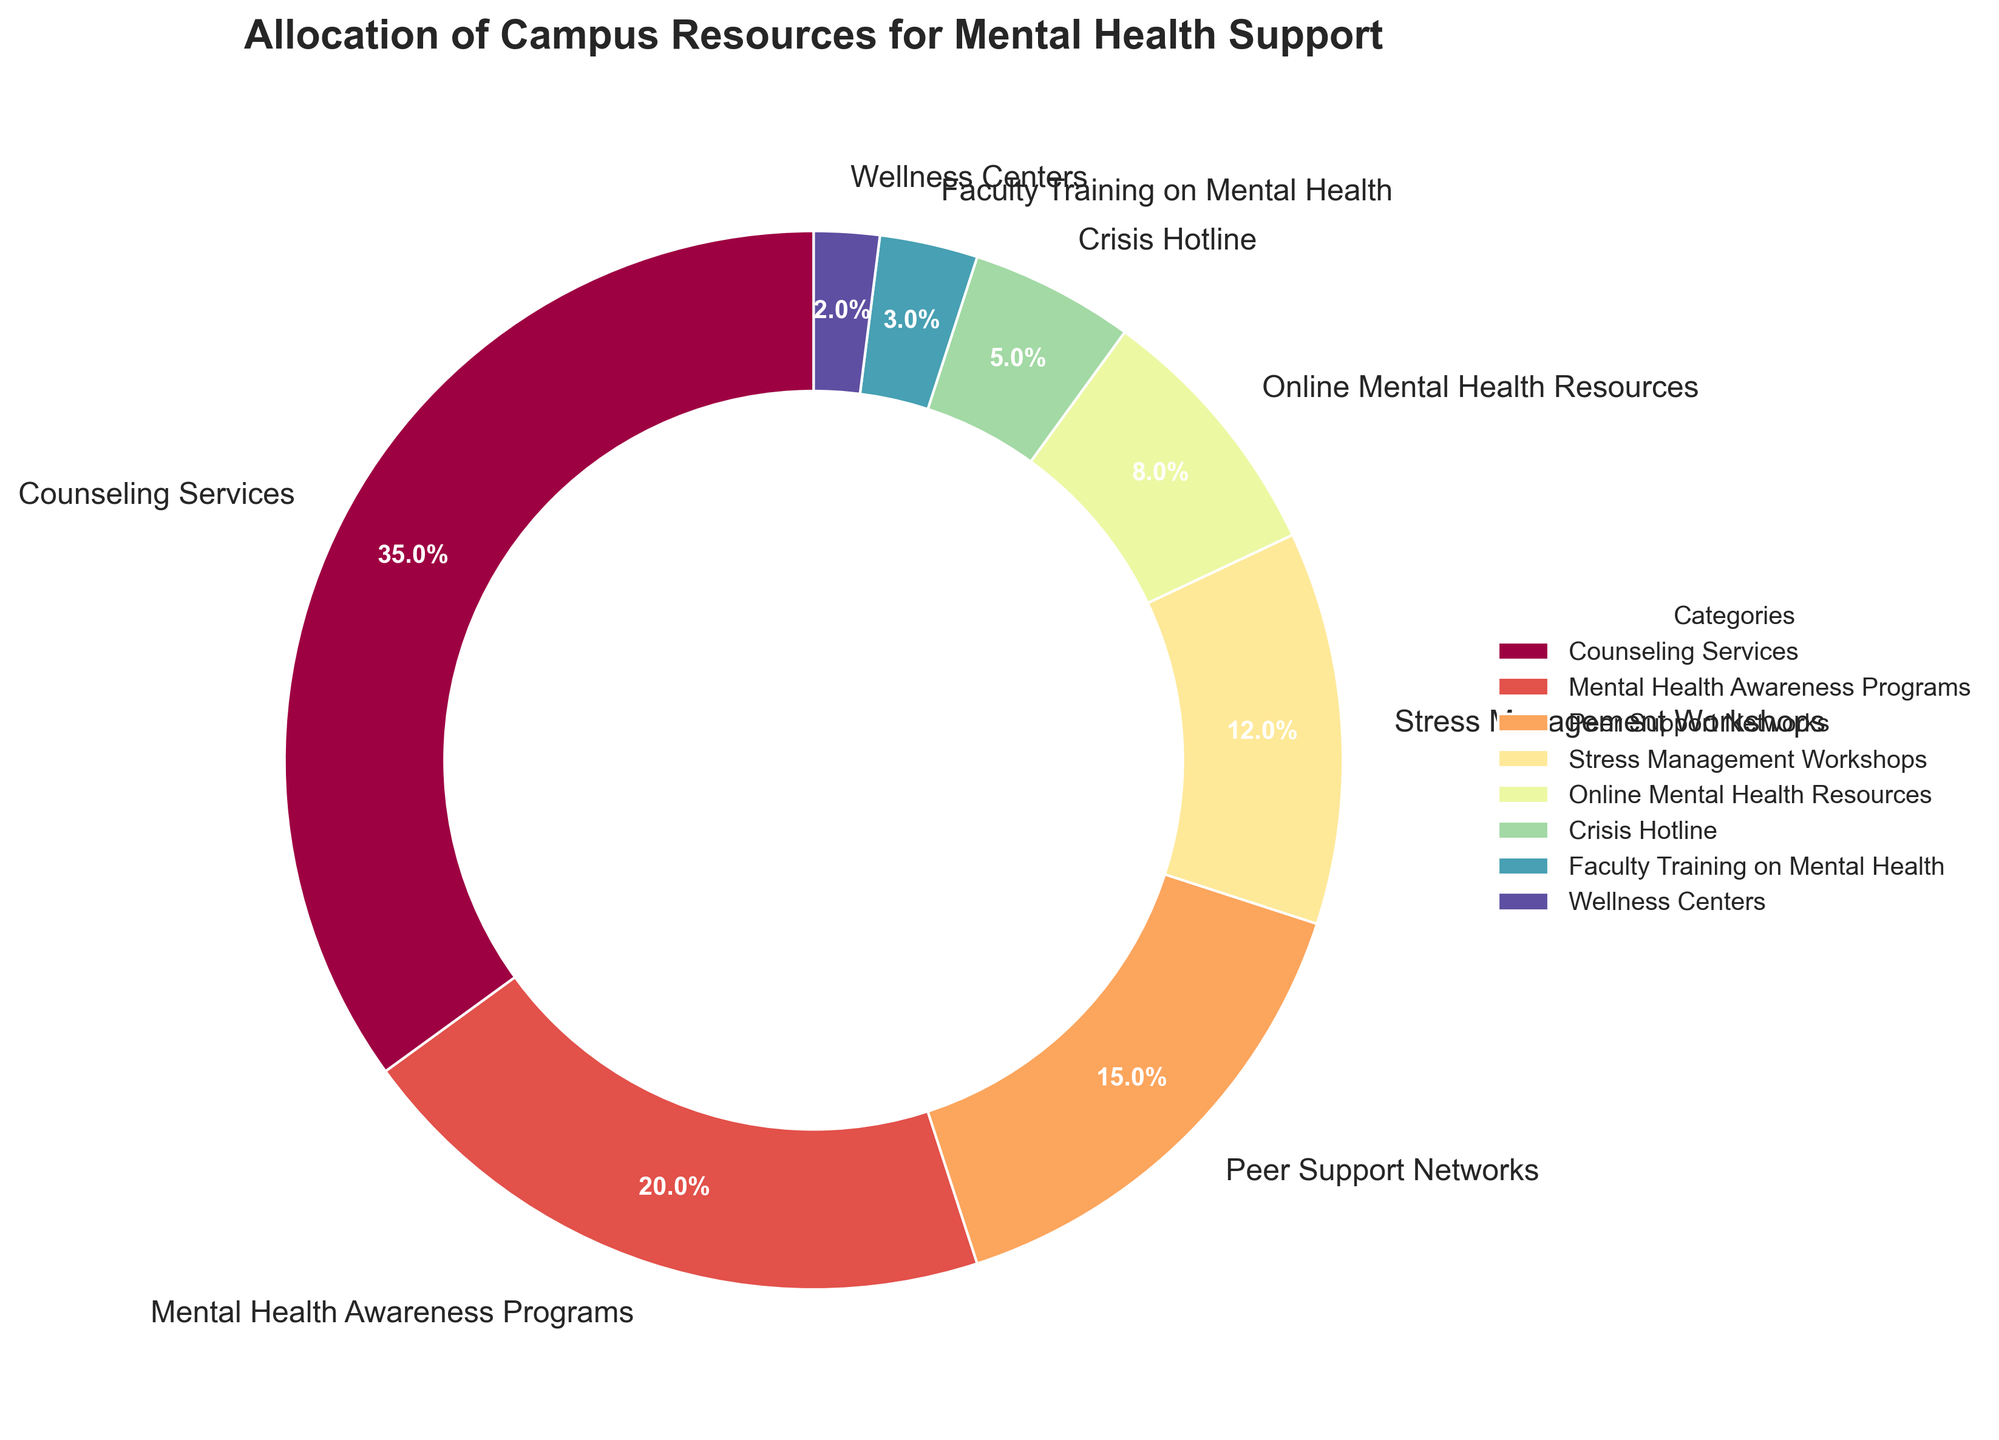What is the largest category in the figure? The largest category is the one with the highest percentage. Based on the figure, Counseling Services has the highest percentage at 35%.
Answer: Counseling Services What is the combined percentage of Peer Support Networks and Stress Management Workshops? To find the combined percentage, add the percentage of Peer Support Networks (15%) to the percentage of Stress Management Workshops (12%). 15% + 12% = 27%
Answer: 27% Which categories have a lower percentage than Online Mental Health Resources? The categories that have a lower percentage than Online Mental Health Resources (8%) are Crisis Hotline (5%), Faculty Training on Mental Health (3%), and Wellness Centers (2%).
Answer: Crisis Hotline, Faculty Training on Mental Health, Wellness Centers How much more percentage is allocated to Counseling Services compared to Crisis Hotline? To find the difference, subtract the percentage of Crisis Hotline (5%) from the percentage of Counseling Services (35%). 35% - 5% = 30%
Answer: 30% What is the total percentage allotted to categories with names starting with 'M'? Categories starting with 'M' are Mental Health Awareness Programs (20%) and Mental Health Resources (8%). Add their percentages: 20% + 8% = 28%
Answer: 28% Which category has the smallest percentage? The smallest category is the one with the lowest percentage. Based on the figure, Wellness Centers have the lowest percentage at 2%.
Answer: Wellness Centers What is the difference between the percentages of Stress Management Workshops and Peer Support Networks? To find the difference, subtract the percentage of Stress Management Workshops (12%) from that of Peer Support Networks (15%). 15% - 12% = 3%
Answer: 3% Is the percentage allocated to Stress Management Workshops greater than or equal to the combined percentage of Crisis Hotline and Online Mental Health Resources? The combined percentage of Crisis Hotline (5%) and Online Mental Health Resources (8%) is 5% + 8% = 13%. Stress Management Workshops is 12%, which is less than 13%.
Answer: No Which category uses a yellow color in the pie chart? Each wedge in the pie chart is colored differently according to the categories. Based on typical color schemes where yellow is often used for middle values, Mental Health Awareness Programs (20%) often get the yellow color.
Answer: Mental Health Awareness Programs What's the average percentage of the top three categories? The top three categories are Counseling Services (35%), Mental Health Awareness Programs (20%), and Peer Support Networks (15%). Their total percentage is 35% + 20% + 15% = 70%. Dividing by 3 gives 70% / 3 ≈ 23.33%.
Answer: 23.33% 